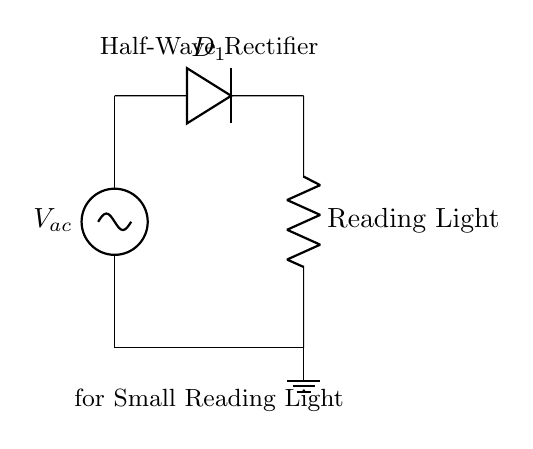What type of rectifier is this circuit? The diagram shows a half-wave rectifier, identifiable by the single diode that allows current to pass only during one half of the AC cycle.
Answer: Half-wave rectifier What component is used to convert AC to DC? The component responsible for the conversion in this circuit is the diode, which directs the flow of current in one direction only, preventing the reverse flow.
Answer: Diode What does the load resistor represent in the circuit? The load resistor here is labeled as the reading light, indicating that this component represents the device being powered by the rectifier output.
Answer: Reading light How many diodes are present in this circuit? The circuit features a single diode connected to the AC source, which serves to rectify the incoming voltage to power the load.
Answer: One What happens to the current direction during the negative half-cycle of the AC input? During the negative half-cycle, the diode becomes reverse-biased, blocking current flow and resulting in no output to the load, which is a characteristic behavior of half-wave rectifiers.
Answer: No current What is the purpose of the ground connection in this circuit? The ground connection serves as a reference point for the entire circuit, ensuring safety and completing the circuit path for the return flow of current.
Answer: Safety and reference What kind of waveform would result from this circuit? The output waveform from a half-wave rectifier is characterized by only the positive half-cycles of the input AC waveform being allowed through, resulting in a pulsed DC signal.
Answer: Pulsed DC 